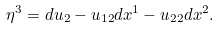Convert formula to latex. <formula><loc_0><loc_0><loc_500><loc_500>\eta ^ { 3 } = d u _ { 2 } - u _ { 1 2 } d x ^ { 1 } - u _ { 2 2 } d x ^ { 2 } .</formula> 